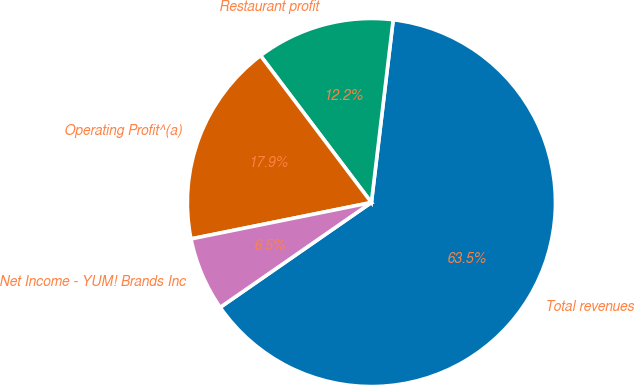Convert chart to OTSL. <chart><loc_0><loc_0><loc_500><loc_500><pie_chart><fcel>Total revenues<fcel>Restaurant profit<fcel>Operating Profit^(a)<fcel>Net Income - YUM! Brands Inc<nl><fcel>63.47%<fcel>12.18%<fcel>17.88%<fcel>6.48%<nl></chart> 